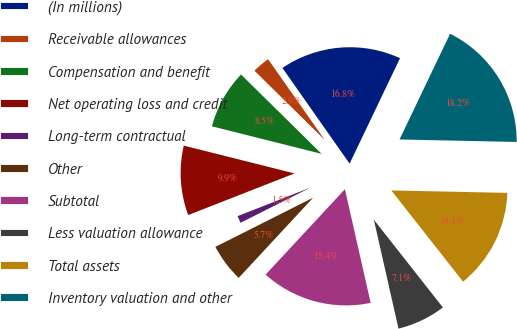Convert chart. <chart><loc_0><loc_0><loc_500><loc_500><pie_chart><fcel>(In millions)<fcel>Receivable allowances<fcel>Compensation and benefit<fcel>Net operating loss and credit<fcel>Long-term contractual<fcel>Other<fcel>Subtotal<fcel>Less valuation allowance<fcel>Total assets<fcel>Inventory valuation and other<nl><fcel>16.84%<fcel>2.88%<fcel>8.46%<fcel>9.86%<fcel>1.48%<fcel>5.67%<fcel>15.45%<fcel>7.07%<fcel>14.05%<fcel>18.24%<nl></chart> 